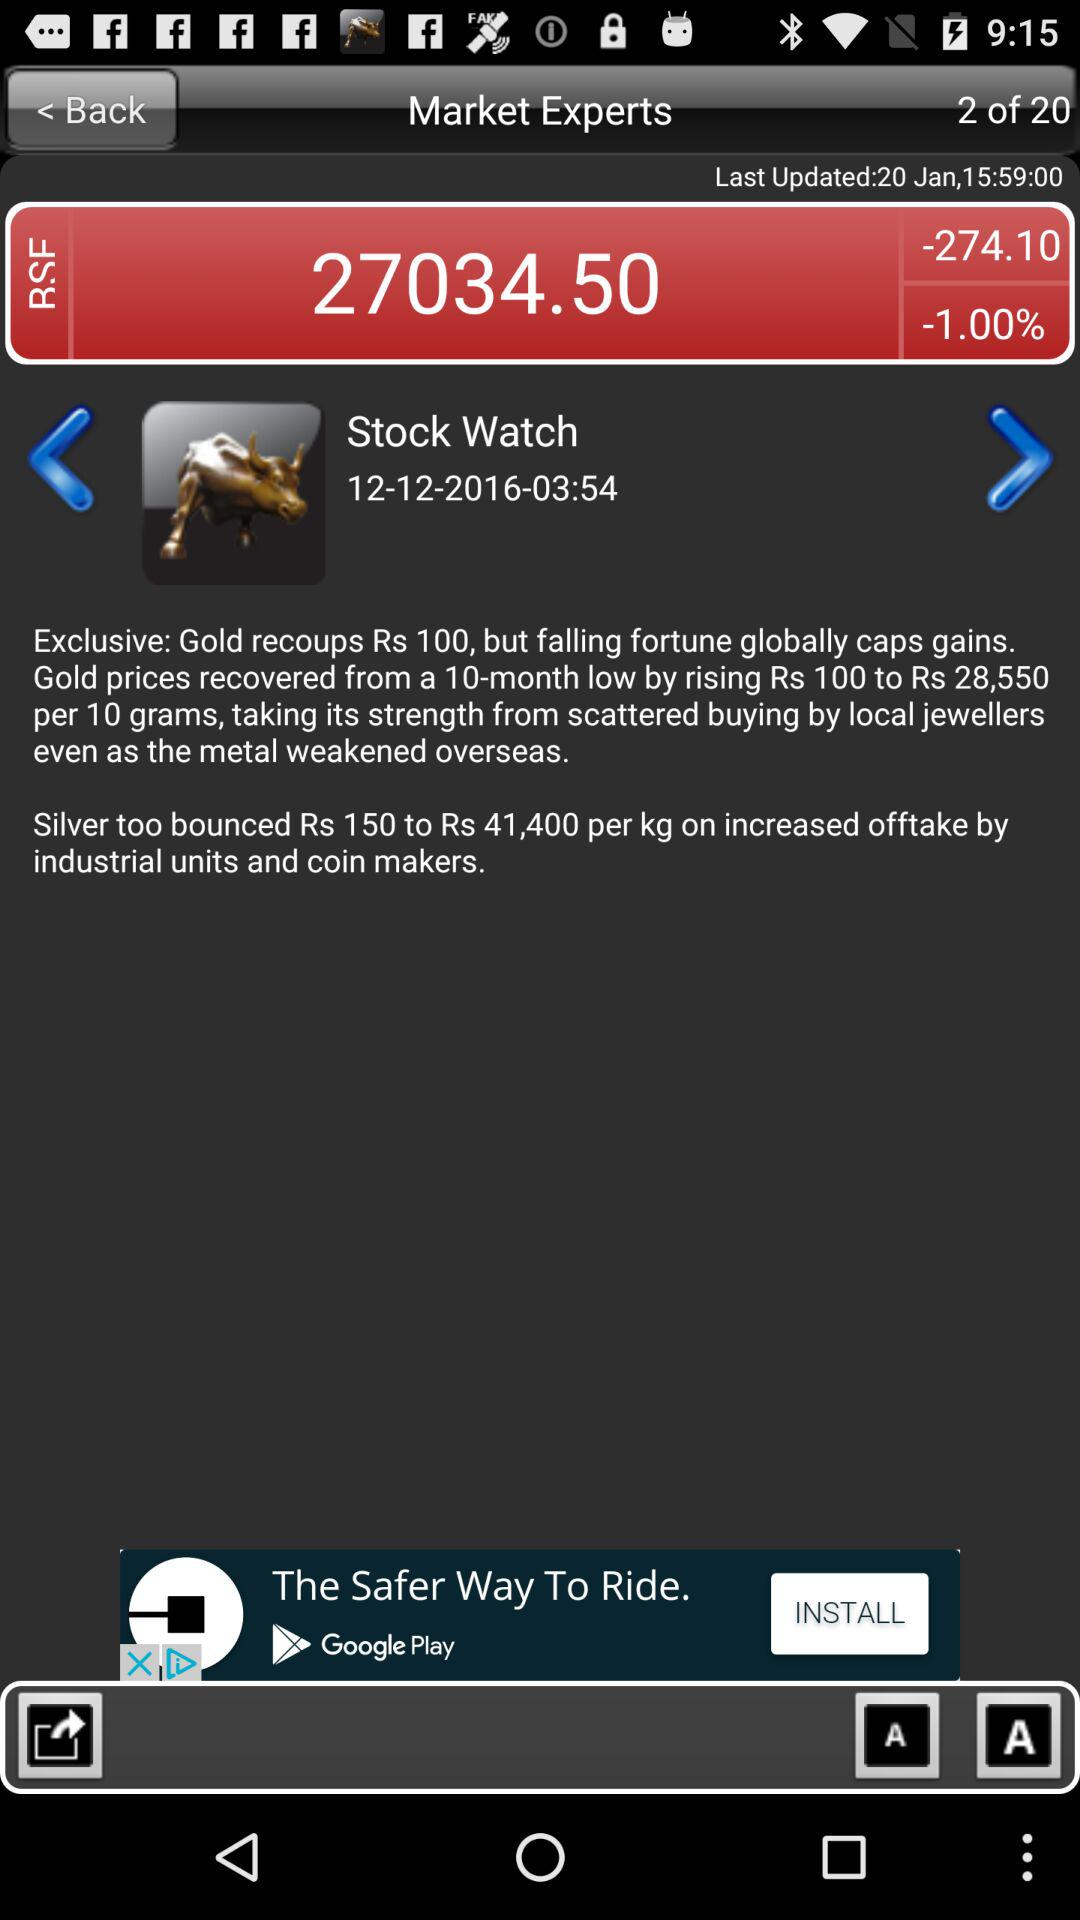How much has Gold prices recovered in Rs?
Answer the question using a single word or phrase. 100 